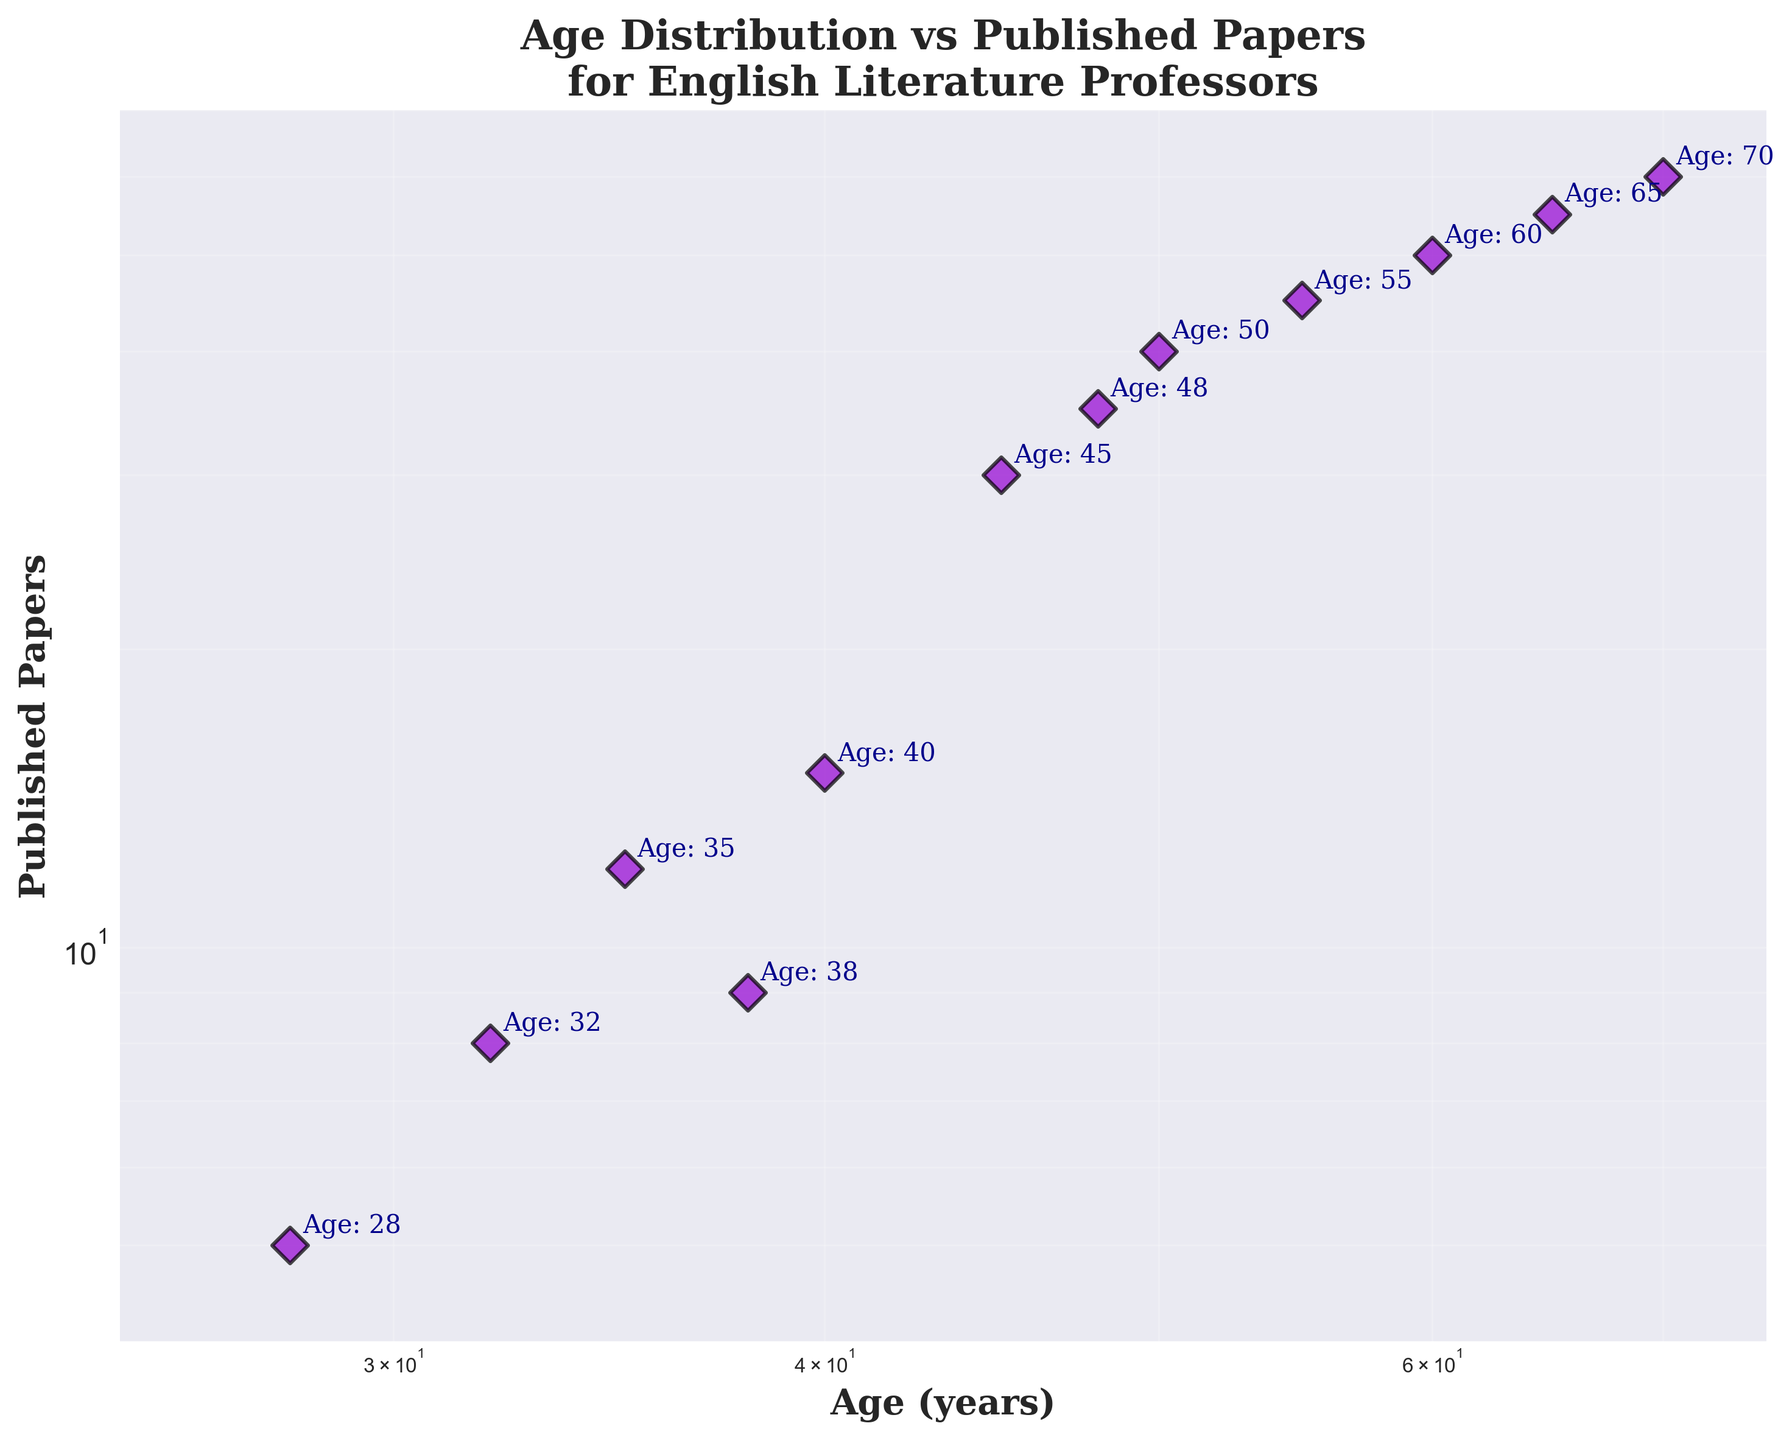What's the title of the plot? The title of the plot is displayed at the top center of the figure. It is a textual description summarizing the plot.
Answer: Age Distribution vs Published Papers for English Literature Professors What are the units used for the axes in this plot? The x-axis represents Age in years and the y-axis represents the number of Published Papers. The labels for the axes indicate these units.
Answer: Age (years), Published Papers What is the range of the x-axis? The x-axis has limits set from 25 to 75, as seen by the minimum and maximum values on the axis.
Answer: 25 to 75 Why are both axes on a log scale? Both axes are on a log scale to better visualize the data, as it spans multiple orders of magnitude. A log scale allows for a more intuitive comparison of rates of change or exponential growth.
Answer: To better visualize data spanning multiple orders of magnitude Which age group has published the most papers? The data point at age 70 corresponds to the highest number of published papers, which is 60.
Answer: Age 70 Compare the number of papers published by a 45-year-old and a 65-year-old professor. Who has published more? By looking at the plot, the data point at age 45 shows 30 papers published while at age 65, 55 papers are published. Thus, the 65-year-old professor has published more.
Answer: 65-year-old professor What is the difference in the number of published papers between a 32-year-old and a 50-year-old professor? From the plot, the 32-year-old professor has published 8 papers, while the 50-year-old professor has published 40 papers. The difference is 40 - 8.
Answer: 32 papers What is the general trend observable from the scatter plot between age and published papers? Observing the scatter plot, there is a general upward trend, indicating that older professors tend to have published more papers than younger professors.
Answer: Older professors published more papers What is the average number of published papers for professors aged 60 and above? Identifying the professors aged 60, 65, and 70, they have published 50, 55, and 60 papers respectively. The average is calculated as (50 + 55 + 60) / 3.
Answer: 55 papers How many data points are displayed in the scatter plot? By counting the individual data points or annotations for age, we find there are 12 data points.
Answer: 12 